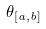Convert formula to latex. <formula><loc_0><loc_0><loc_500><loc_500>\theta _ { [ a , b ] }</formula> 